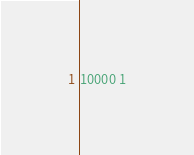Convert code to text. <code><loc_0><loc_0><loc_500><loc_500><_Python_>10000 1</code> 